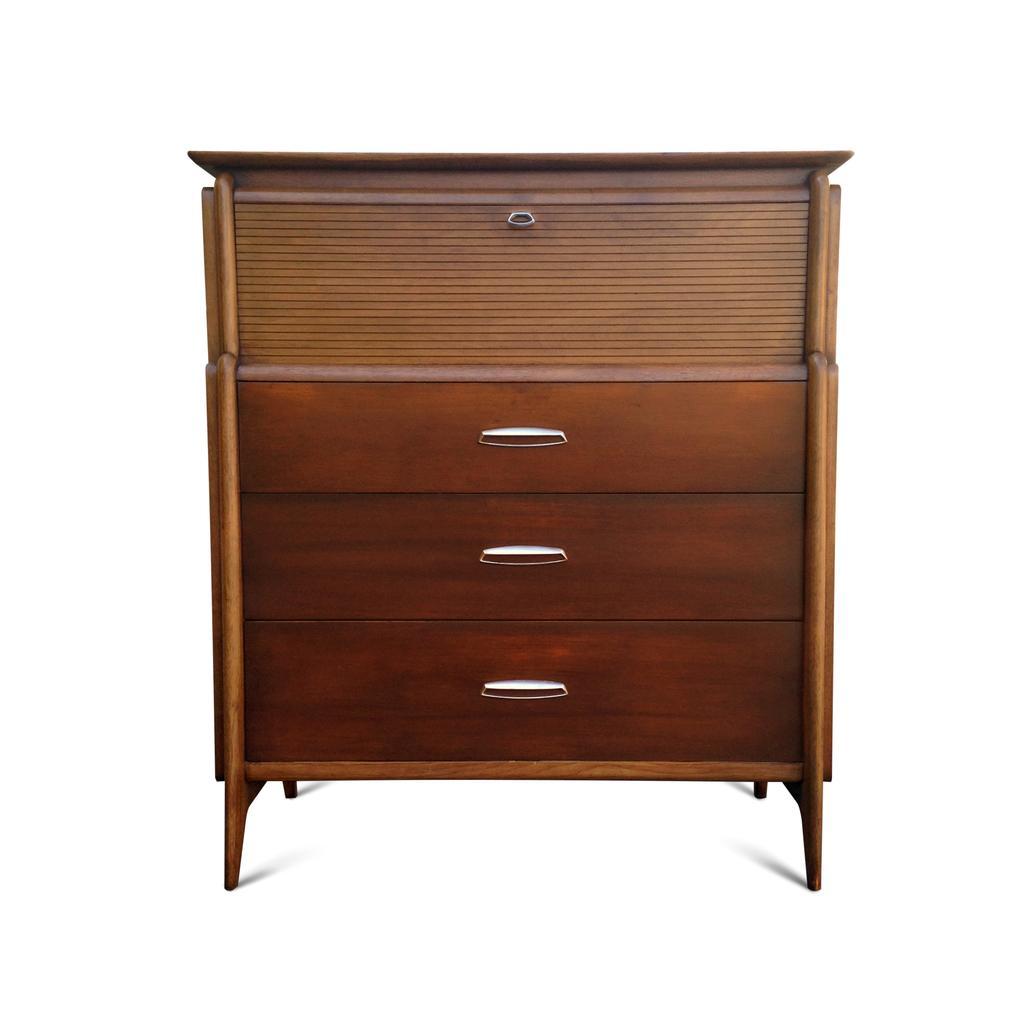Please provide a concise description of this image. In this picture we can see cupboard with racks and handles to it. 